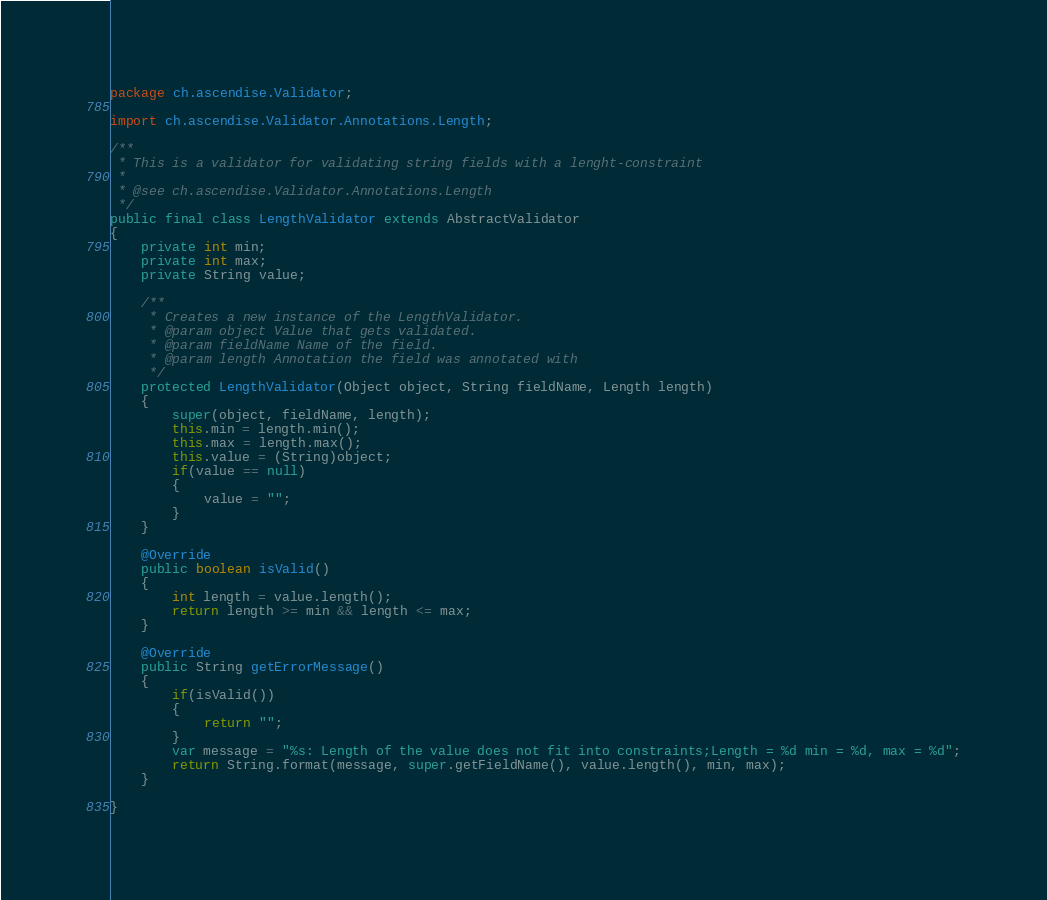<code> <loc_0><loc_0><loc_500><loc_500><_Java_>package ch.ascendise.Validator;

import ch.ascendise.Validator.Annotations.Length;

/**
 * This is a validator for validating string fields with a lenght-constraint
 * 
 * @see ch.ascendise.Validator.Annotations.Length
 */
public final class LengthValidator extends AbstractValidator
{
	private int min;
	private int max;
	private String value;

	/**
	 * Creates a new instance of the LengthValidator.
	 * @param object Value that gets validated.
	 * @param fieldName Name of the field.
	 * @param length Annotation the field was annotated with
	 */
	protected LengthValidator(Object object, String fieldName, Length length)
	{
		super(object, fieldName, length);
		this.min = length.min();
		this.max = length.max();
		this.value = (String)object;
		if(value == null)
		{
			value = "";
		}
	}

	@Override
	public boolean isValid() 
	{
		int length = value.length();
		return length >= min && length <= max;
	}

	@Override
	public String getErrorMessage() 
	{
		if(isValid())
		{
			return "";
		}
		var message = "%s: Length of the value does not fit into constraints;Length = %d min = %d, max = %d";
		return String.format(message, super.getFieldName(), value.length(), min, max);
	}

}
</code> 